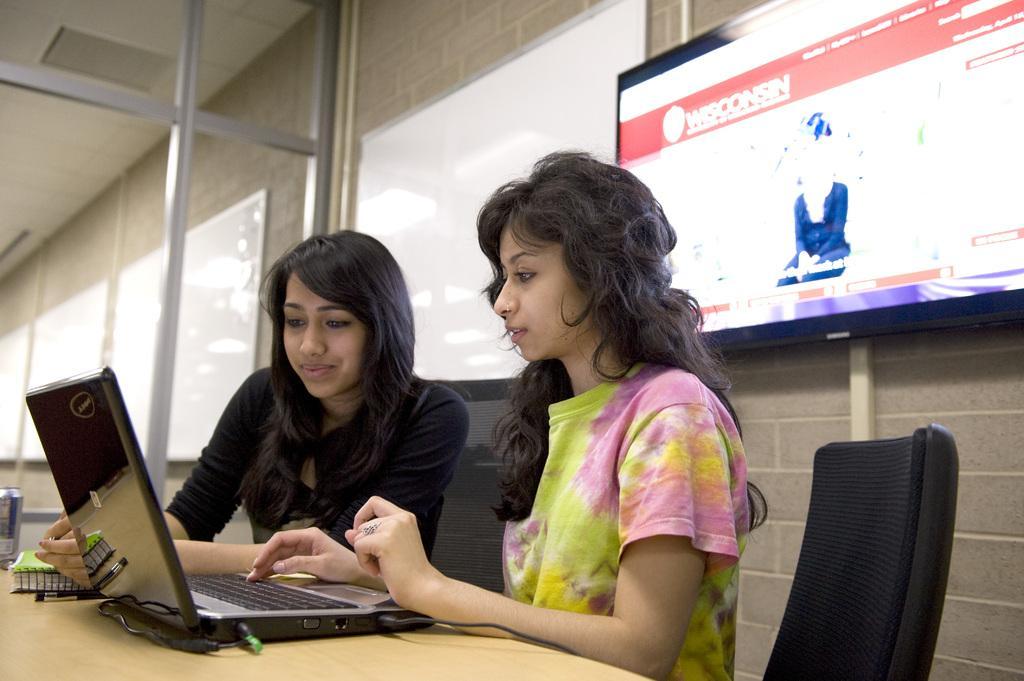In one or two sentences, can you explain what this image depicts? In the picture we can find two women are sitting on the chairs near the table and they are finding something on the laptop screen. In the background we can find a television connected to the wall. And the windows, glasses. And one woman is wearing a black T-shirt and other is wearing a color T-shirt. 